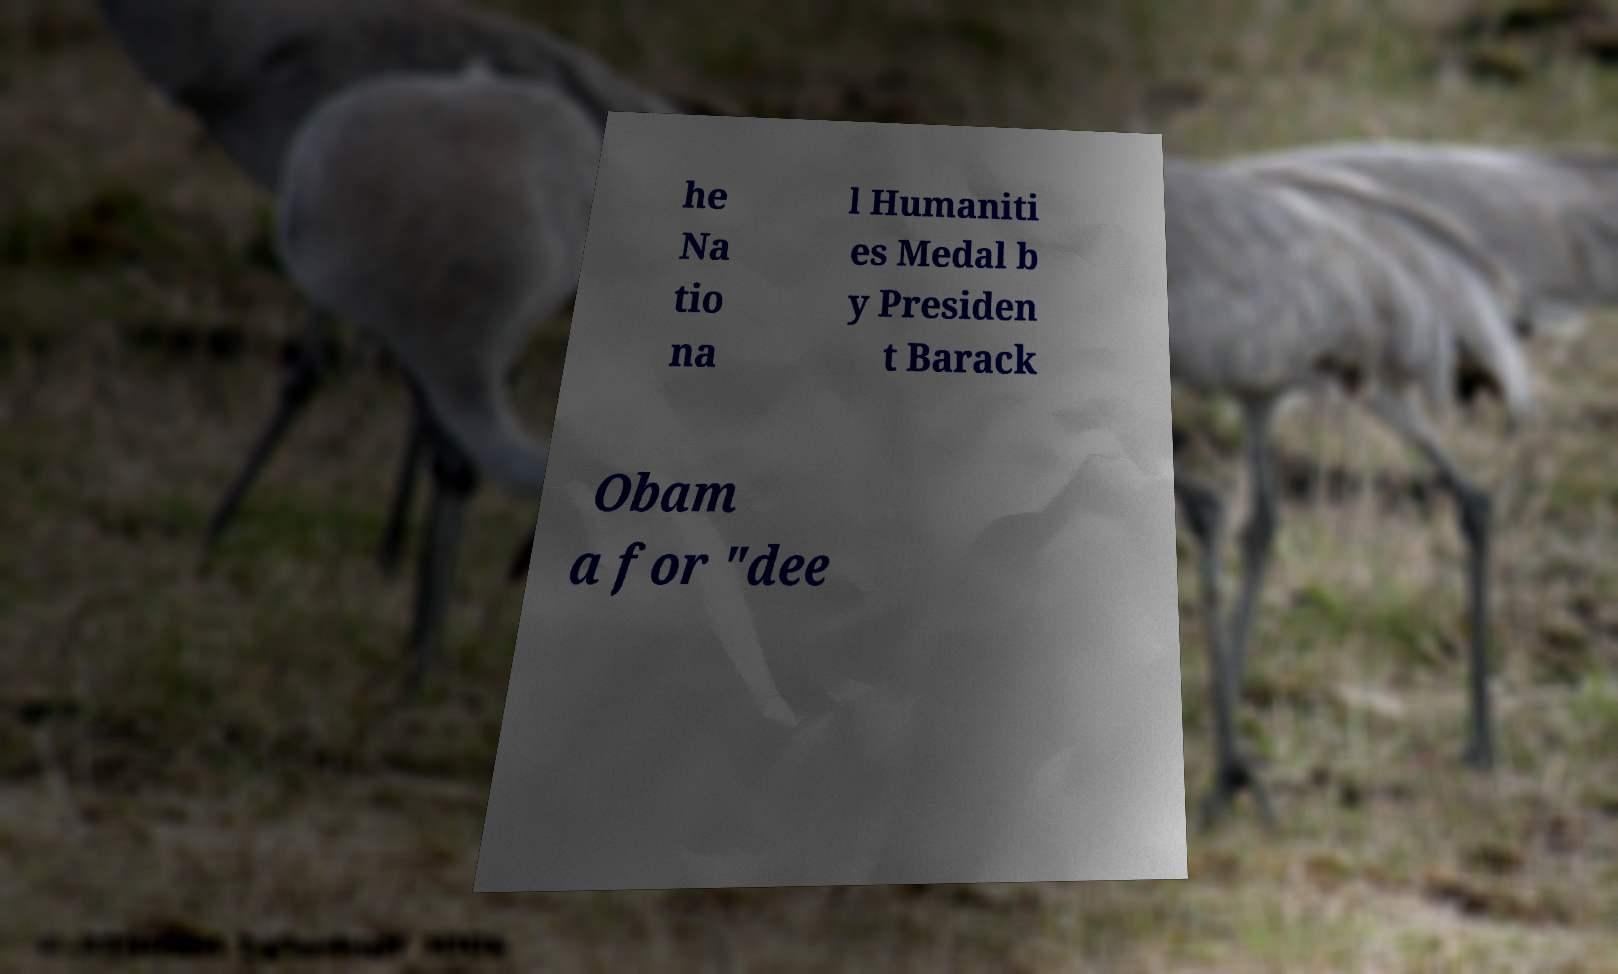Please read and relay the text visible in this image. What does it say? he Na tio na l Humaniti es Medal b y Presiden t Barack Obam a for "dee 